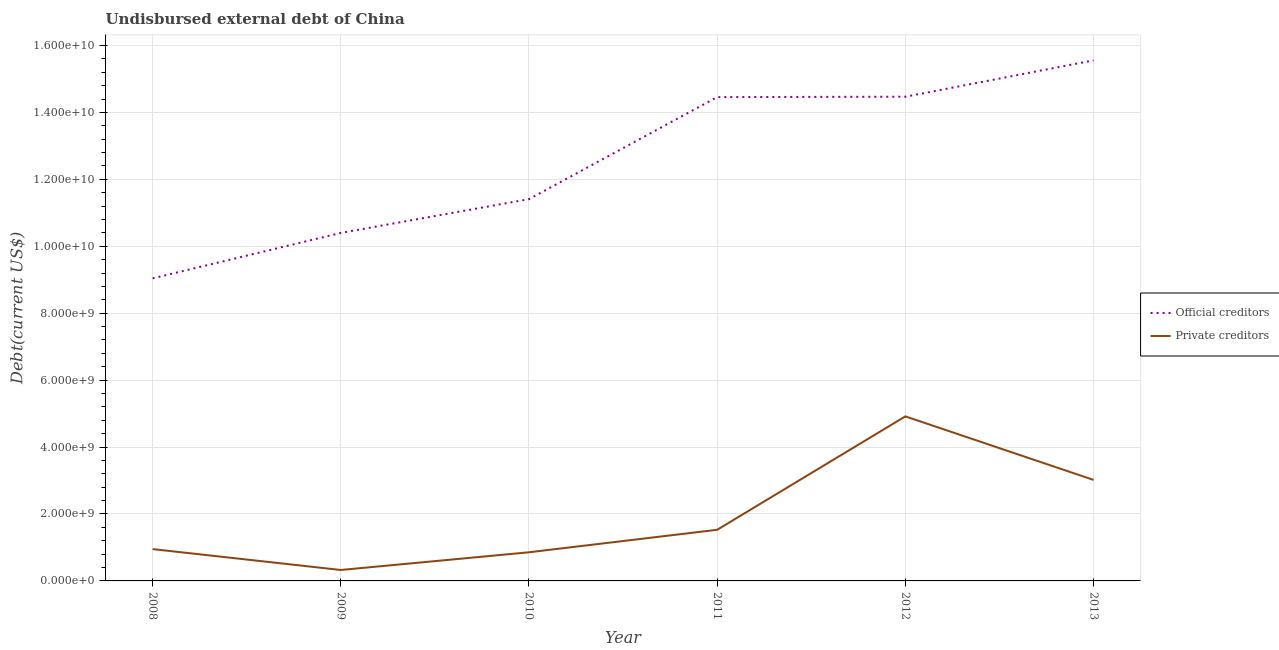What is the undisbursed external debt of private creditors in 2008?
Your answer should be very brief. 9.51e+08. Across all years, what is the maximum undisbursed external debt of official creditors?
Ensure brevity in your answer.  1.56e+1. Across all years, what is the minimum undisbursed external debt of official creditors?
Provide a succinct answer. 9.04e+09. In which year was the undisbursed external debt of private creditors maximum?
Offer a terse response. 2012. What is the total undisbursed external debt of official creditors in the graph?
Make the answer very short. 7.53e+1. What is the difference between the undisbursed external debt of official creditors in 2008 and that in 2013?
Keep it short and to the point. -6.51e+09. What is the difference between the undisbursed external debt of private creditors in 2011 and the undisbursed external debt of official creditors in 2008?
Provide a short and direct response. -7.51e+09. What is the average undisbursed external debt of official creditors per year?
Your response must be concise. 1.26e+1. In the year 2011, what is the difference between the undisbursed external debt of private creditors and undisbursed external debt of official creditors?
Provide a succinct answer. -1.29e+1. What is the ratio of the undisbursed external debt of official creditors in 2008 to that in 2013?
Give a very brief answer. 0.58. Is the difference between the undisbursed external debt of private creditors in 2008 and 2011 greater than the difference between the undisbursed external debt of official creditors in 2008 and 2011?
Keep it short and to the point. Yes. What is the difference between the highest and the second highest undisbursed external debt of private creditors?
Provide a short and direct response. 1.90e+09. What is the difference between the highest and the lowest undisbursed external debt of private creditors?
Your response must be concise. 4.59e+09. How many lines are there?
Keep it short and to the point. 2. What is the difference between two consecutive major ticks on the Y-axis?
Ensure brevity in your answer.  2.00e+09. Are the values on the major ticks of Y-axis written in scientific E-notation?
Give a very brief answer. Yes. Does the graph contain any zero values?
Keep it short and to the point. No. What is the title of the graph?
Offer a terse response. Undisbursed external debt of China. Does "Female population" appear as one of the legend labels in the graph?
Your answer should be compact. No. What is the label or title of the Y-axis?
Ensure brevity in your answer.  Debt(current US$). What is the Debt(current US$) of Official creditors in 2008?
Provide a succinct answer. 9.04e+09. What is the Debt(current US$) of Private creditors in 2008?
Offer a very short reply. 9.51e+08. What is the Debt(current US$) of Official creditors in 2009?
Provide a short and direct response. 1.04e+1. What is the Debt(current US$) in Private creditors in 2009?
Offer a terse response. 3.27e+08. What is the Debt(current US$) of Official creditors in 2010?
Offer a terse response. 1.14e+1. What is the Debt(current US$) in Private creditors in 2010?
Ensure brevity in your answer.  8.56e+08. What is the Debt(current US$) of Official creditors in 2011?
Provide a succinct answer. 1.45e+1. What is the Debt(current US$) in Private creditors in 2011?
Ensure brevity in your answer.  1.53e+09. What is the Debt(current US$) of Official creditors in 2012?
Offer a very short reply. 1.45e+1. What is the Debt(current US$) of Private creditors in 2012?
Your response must be concise. 4.92e+09. What is the Debt(current US$) in Official creditors in 2013?
Your response must be concise. 1.56e+1. What is the Debt(current US$) of Private creditors in 2013?
Provide a short and direct response. 3.02e+09. Across all years, what is the maximum Debt(current US$) in Official creditors?
Make the answer very short. 1.56e+1. Across all years, what is the maximum Debt(current US$) in Private creditors?
Provide a succinct answer. 4.92e+09. Across all years, what is the minimum Debt(current US$) in Official creditors?
Your answer should be compact. 9.04e+09. Across all years, what is the minimum Debt(current US$) of Private creditors?
Make the answer very short. 3.27e+08. What is the total Debt(current US$) in Official creditors in the graph?
Offer a very short reply. 7.53e+1. What is the total Debt(current US$) of Private creditors in the graph?
Offer a terse response. 1.16e+1. What is the difference between the Debt(current US$) in Official creditors in 2008 and that in 2009?
Provide a succinct answer. -1.36e+09. What is the difference between the Debt(current US$) in Private creditors in 2008 and that in 2009?
Offer a very short reply. 6.24e+08. What is the difference between the Debt(current US$) in Official creditors in 2008 and that in 2010?
Make the answer very short. -2.37e+09. What is the difference between the Debt(current US$) in Private creditors in 2008 and that in 2010?
Offer a very short reply. 9.51e+07. What is the difference between the Debt(current US$) of Official creditors in 2008 and that in 2011?
Give a very brief answer. -5.42e+09. What is the difference between the Debt(current US$) in Private creditors in 2008 and that in 2011?
Offer a very short reply. -5.77e+08. What is the difference between the Debt(current US$) of Official creditors in 2008 and that in 2012?
Your answer should be very brief. -5.43e+09. What is the difference between the Debt(current US$) in Private creditors in 2008 and that in 2012?
Your response must be concise. -3.97e+09. What is the difference between the Debt(current US$) in Official creditors in 2008 and that in 2013?
Offer a very short reply. -6.51e+09. What is the difference between the Debt(current US$) of Private creditors in 2008 and that in 2013?
Your answer should be compact. -2.07e+09. What is the difference between the Debt(current US$) of Official creditors in 2009 and that in 2010?
Your answer should be very brief. -1.01e+09. What is the difference between the Debt(current US$) of Private creditors in 2009 and that in 2010?
Offer a terse response. -5.29e+08. What is the difference between the Debt(current US$) in Official creditors in 2009 and that in 2011?
Ensure brevity in your answer.  -4.06e+09. What is the difference between the Debt(current US$) of Private creditors in 2009 and that in 2011?
Ensure brevity in your answer.  -1.20e+09. What is the difference between the Debt(current US$) of Official creditors in 2009 and that in 2012?
Your answer should be very brief. -4.07e+09. What is the difference between the Debt(current US$) in Private creditors in 2009 and that in 2012?
Offer a very short reply. -4.59e+09. What is the difference between the Debt(current US$) of Official creditors in 2009 and that in 2013?
Give a very brief answer. -5.16e+09. What is the difference between the Debt(current US$) of Private creditors in 2009 and that in 2013?
Make the answer very short. -2.69e+09. What is the difference between the Debt(current US$) in Official creditors in 2010 and that in 2011?
Your response must be concise. -3.05e+09. What is the difference between the Debt(current US$) of Private creditors in 2010 and that in 2011?
Keep it short and to the point. -6.72e+08. What is the difference between the Debt(current US$) of Official creditors in 2010 and that in 2012?
Offer a terse response. -3.06e+09. What is the difference between the Debt(current US$) of Private creditors in 2010 and that in 2012?
Offer a very short reply. -4.06e+09. What is the difference between the Debt(current US$) in Official creditors in 2010 and that in 2013?
Ensure brevity in your answer.  -4.15e+09. What is the difference between the Debt(current US$) of Private creditors in 2010 and that in 2013?
Offer a terse response. -2.16e+09. What is the difference between the Debt(current US$) of Official creditors in 2011 and that in 2012?
Keep it short and to the point. -1.13e+07. What is the difference between the Debt(current US$) in Private creditors in 2011 and that in 2012?
Provide a short and direct response. -3.39e+09. What is the difference between the Debt(current US$) in Official creditors in 2011 and that in 2013?
Ensure brevity in your answer.  -1.10e+09. What is the difference between the Debt(current US$) in Private creditors in 2011 and that in 2013?
Make the answer very short. -1.49e+09. What is the difference between the Debt(current US$) in Official creditors in 2012 and that in 2013?
Make the answer very short. -1.09e+09. What is the difference between the Debt(current US$) of Private creditors in 2012 and that in 2013?
Your answer should be compact. 1.90e+09. What is the difference between the Debt(current US$) of Official creditors in 2008 and the Debt(current US$) of Private creditors in 2009?
Provide a short and direct response. 8.71e+09. What is the difference between the Debt(current US$) in Official creditors in 2008 and the Debt(current US$) in Private creditors in 2010?
Offer a terse response. 8.18e+09. What is the difference between the Debt(current US$) in Official creditors in 2008 and the Debt(current US$) in Private creditors in 2011?
Your answer should be compact. 7.51e+09. What is the difference between the Debt(current US$) in Official creditors in 2008 and the Debt(current US$) in Private creditors in 2012?
Your response must be concise. 4.12e+09. What is the difference between the Debt(current US$) of Official creditors in 2008 and the Debt(current US$) of Private creditors in 2013?
Make the answer very short. 6.02e+09. What is the difference between the Debt(current US$) of Official creditors in 2009 and the Debt(current US$) of Private creditors in 2010?
Your answer should be compact. 9.54e+09. What is the difference between the Debt(current US$) in Official creditors in 2009 and the Debt(current US$) in Private creditors in 2011?
Offer a terse response. 8.87e+09. What is the difference between the Debt(current US$) in Official creditors in 2009 and the Debt(current US$) in Private creditors in 2012?
Provide a short and direct response. 5.48e+09. What is the difference between the Debt(current US$) in Official creditors in 2009 and the Debt(current US$) in Private creditors in 2013?
Provide a succinct answer. 7.38e+09. What is the difference between the Debt(current US$) of Official creditors in 2010 and the Debt(current US$) of Private creditors in 2011?
Offer a terse response. 9.88e+09. What is the difference between the Debt(current US$) in Official creditors in 2010 and the Debt(current US$) in Private creditors in 2012?
Keep it short and to the point. 6.49e+09. What is the difference between the Debt(current US$) of Official creditors in 2010 and the Debt(current US$) of Private creditors in 2013?
Your response must be concise. 8.39e+09. What is the difference between the Debt(current US$) of Official creditors in 2011 and the Debt(current US$) of Private creditors in 2012?
Offer a terse response. 9.54e+09. What is the difference between the Debt(current US$) of Official creditors in 2011 and the Debt(current US$) of Private creditors in 2013?
Keep it short and to the point. 1.14e+1. What is the difference between the Debt(current US$) of Official creditors in 2012 and the Debt(current US$) of Private creditors in 2013?
Keep it short and to the point. 1.15e+1. What is the average Debt(current US$) of Official creditors per year?
Offer a very short reply. 1.26e+1. What is the average Debt(current US$) in Private creditors per year?
Offer a terse response. 1.93e+09. In the year 2008, what is the difference between the Debt(current US$) of Official creditors and Debt(current US$) of Private creditors?
Your answer should be very brief. 8.09e+09. In the year 2009, what is the difference between the Debt(current US$) of Official creditors and Debt(current US$) of Private creditors?
Keep it short and to the point. 1.01e+1. In the year 2010, what is the difference between the Debt(current US$) in Official creditors and Debt(current US$) in Private creditors?
Make the answer very short. 1.06e+1. In the year 2011, what is the difference between the Debt(current US$) of Official creditors and Debt(current US$) of Private creditors?
Keep it short and to the point. 1.29e+1. In the year 2012, what is the difference between the Debt(current US$) in Official creditors and Debt(current US$) in Private creditors?
Make the answer very short. 9.55e+09. In the year 2013, what is the difference between the Debt(current US$) of Official creditors and Debt(current US$) of Private creditors?
Keep it short and to the point. 1.25e+1. What is the ratio of the Debt(current US$) in Official creditors in 2008 to that in 2009?
Give a very brief answer. 0.87. What is the ratio of the Debt(current US$) in Private creditors in 2008 to that in 2009?
Offer a very short reply. 2.91. What is the ratio of the Debt(current US$) in Official creditors in 2008 to that in 2010?
Your response must be concise. 0.79. What is the ratio of the Debt(current US$) in Official creditors in 2008 to that in 2011?
Your answer should be compact. 0.63. What is the ratio of the Debt(current US$) of Private creditors in 2008 to that in 2011?
Your answer should be compact. 0.62. What is the ratio of the Debt(current US$) of Official creditors in 2008 to that in 2012?
Offer a terse response. 0.62. What is the ratio of the Debt(current US$) of Private creditors in 2008 to that in 2012?
Provide a short and direct response. 0.19. What is the ratio of the Debt(current US$) in Official creditors in 2008 to that in 2013?
Your answer should be compact. 0.58. What is the ratio of the Debt(current US$) in Private creditors in 2008 to that in 2013?
Your answer should be very brief. 0.32. What is the ratio of the Debt(current US$) in Official creditors in 2009 to that in 2010?
Ensure brevity in your answer.  0.91. What is the ratio of the Debt(current US$) in Private creditors in 2009 to that in 2010?
Your answer should be very brief. 0.38. What is the ratio of the Debt(current US$) in Official creditors in 2009 to that in 2011?
Ensure brevity in your answer.  0.72. What is the ratio of the Debt(current US$) in Private creditors in 2009 to that in 2011?
Offer a very short reply. 0.21. What is the ratio of the Debt(current US$) in Official creditors in 2009 to that in 2012?
Offer a very short reply. 0.72. What is the ratio of the Debt(current US$) in Private creditors in 2009 to that in 2012?
Offer a terse response. 0.07. What is the ratio of the Debt(current US$) in Official creditors in 2009 to that in 2013?
Provide a succinct answer. 0.67. What is the ratio of the Debt(current US$) of Private creditors in 2009 to that in 2013?
Your answer should be compact. 0.11. What is the ratio of the Debt(current US$) in Official creditors in 2010 to that in 2011?
Your answer should be very brief. 0.79. What is the ratio of the Debt(current US$) in Private creditors in 2010 to that in 2011?
Your answer should be compact. 0.56. What is the ratio of the Debt(current US$) of Official creditors in 2010 to that in 2012?
Offer a terse response. 0.79. What is the ratio of the Debt(current US$) of Private creditors in 2010 to that in 2012?
Give a very brief answer. 0.17. What is the ratio of the Debt(current US$) in Official creditors in 2010 to that in 2013?
Give a very brief answer. 0.73. What is the ratio of the Debt(current US$) in Private creditors in 2010 to that in 2013?
Provide a short and direct response. 0.28. What is the ratio of the Debt(current US$) in Official creditors in 2011 to that in 2012?
Offer a very short reply. 1. What is the ratio of the Debt(current US$) of Private creditors in 2011 to that in 2012?
Give a very brief answer. 0.31. What is the ratio of the Debt(current US$) of Official creditors in 2011 to that in 2013?
Offer a terse response. 0.93. What is the ratio of the Debt(current US$) in Private creditors in 2011 to that in 2013?
Give a very brief answer. 0.51. What is the ratio of the Debt(current US$) of Official creditors in 2012 to that in 2013?
Your response must be concise. 0.93. What is the ratio of the Debt(current US$) of Private creditors in 2012 to that in 2013?
Offer a very short reply. 1.63. What is the difference between the highest and the second highest Debt(current US$) of Official creditors?
Offer a terse response. 1.09e+09. What is the difference between the highest and the second highest Debt(current US$) of Private creditors?
Your answer should be very brief. 1.90e+09. What is the difference between the highest and the lowest Debt(current US$) in Official creditors?
Offer a terse response. 6.51e+09. What is the difference between the highest and the lowest Debt(current US$) in Private creditors?
Offer a very short reply. 4.59e+09. 